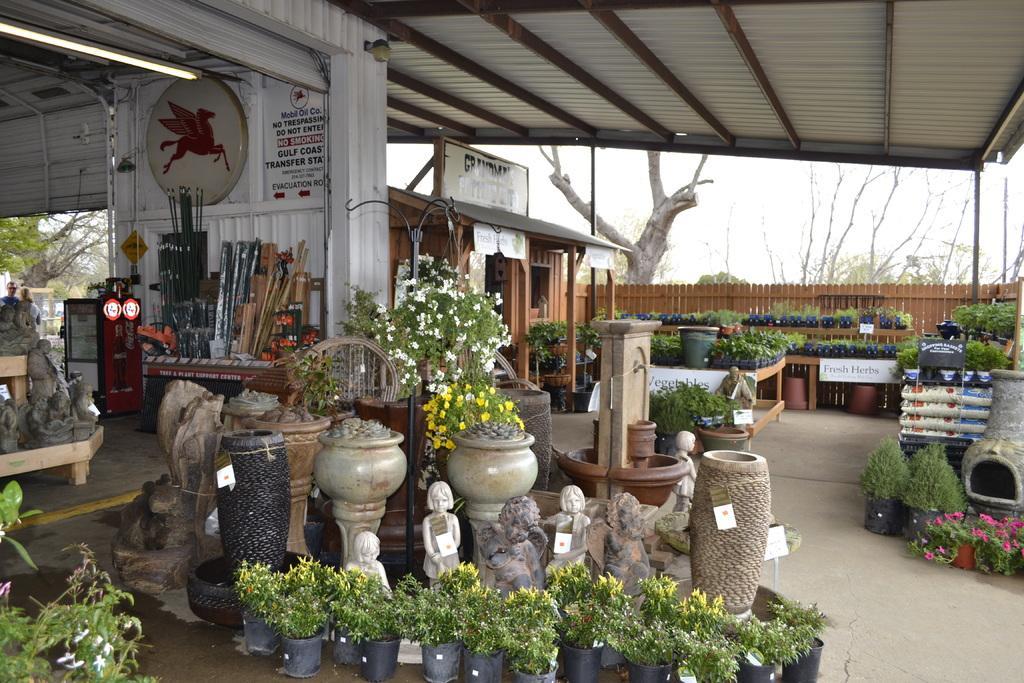In one or two sentences, can you explain what this image depicts? In this picture there are sculptures and there are plants and flowers and flower pots. At the back there are objects on the table and there is a wooden house and wooden railing and there is text on the boards. At the top there is a light and there is a roof. At the back there are trees. At the top there is sky. At the bottom there is a floor. 